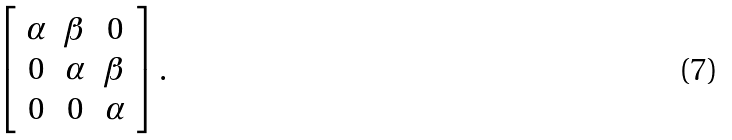Convert formula to latex. <formula><loc_0><loc_0><loc_500><loc_500>\left [ \begin{array} { c c c } \alpha & \beta & 0 \\ 0 & \alpha & \beta \\ 0 & 0 & \alpha \end{array} \right ] .</formula> 